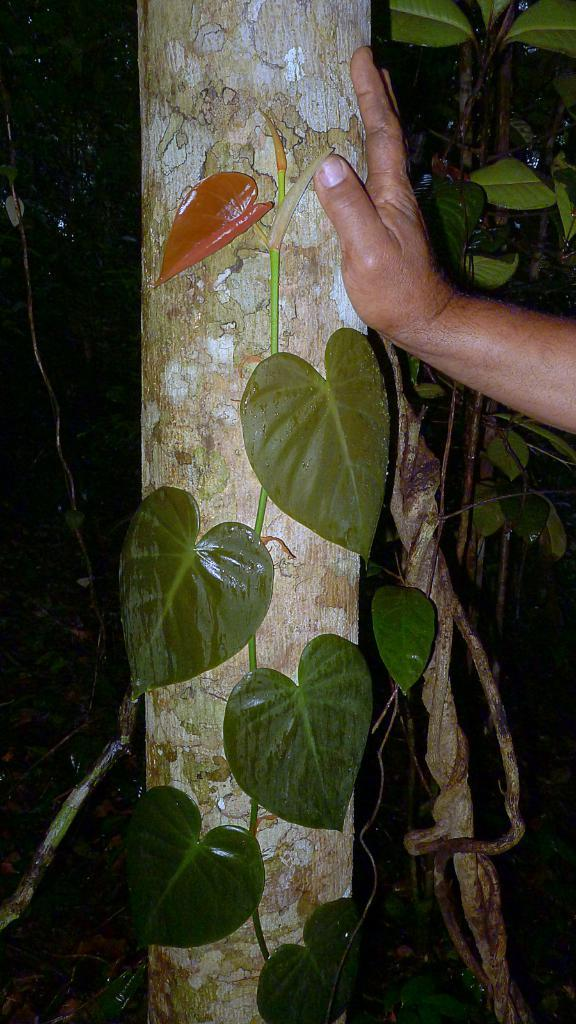What is the main subject of the image? The main subject of the image is a truck. Can you describe any interaction with the truck in the image? Yes, a person's hand is on the truck. What type of vegetation can be seen in the image? There are green color leaves in the image. What is the color of the background in the image? The background of the image is black. Can you tell me how many berries are on the hill in the image? There are no berries or hills present in the image; it features a truck with a person's hand on it, green leaves, and a black background. 